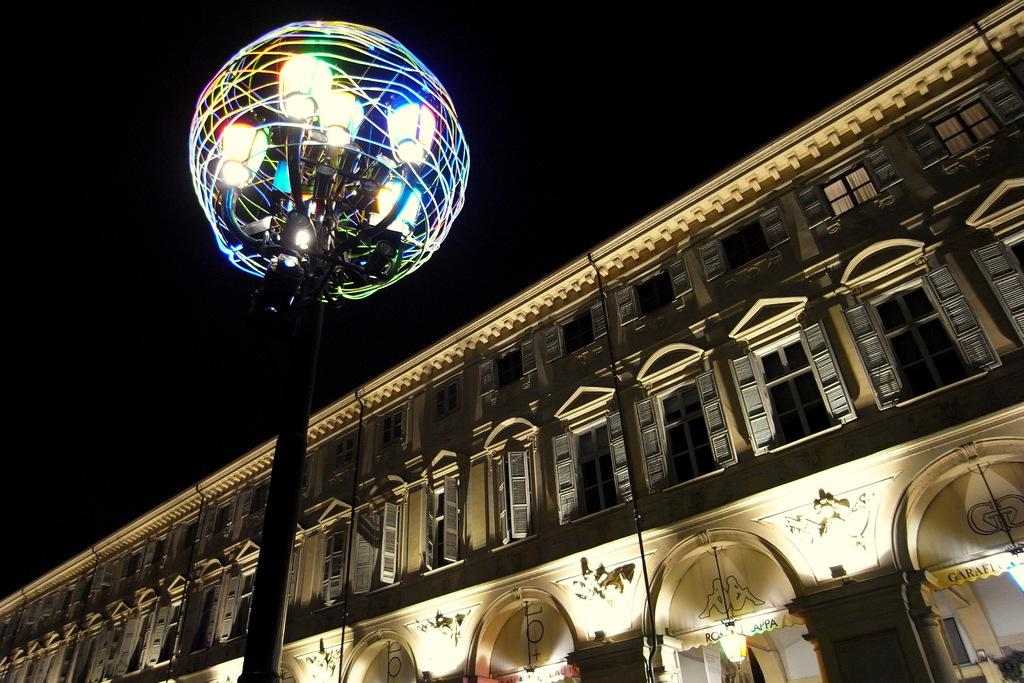What structure is located on the right side of the image? There is a building on the right side of the image. What feature of the building is mentioned in the facts? The building has many windows. What is in the middle of the image? There is a pole in the middle of the image. What is attached to the pole? There are lights attached to the pole. Can you tell me what book the building is reading in the image? There is no book or reading activity depicted in the image; it features a building with many windows and a pole with lights attached. Is there a flight taking off from the building in the image? There is no flight or any indication of an airport or airplane in the image; it only shows a building with windows and a pole with lights. 